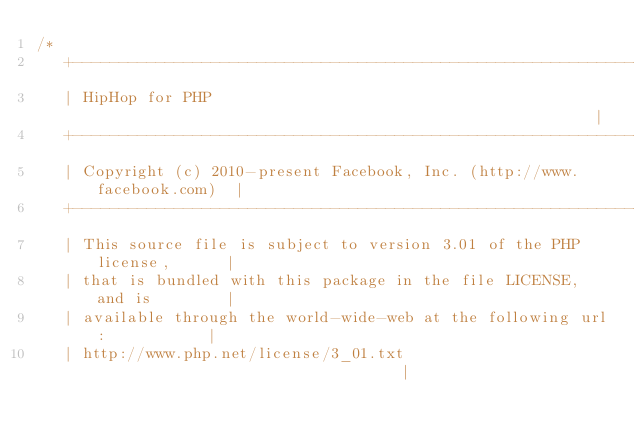<code> <loc_0><loc_0><loc_500><loc_500><_C_>/*
   +----------------------------------------------------------------------+
   | HipHop for PHP                                                       |
   +----------------------------------------------------------------------+
   | Copyright (c) 2010-present Facebook, Inc. (http://www.facebook.com)  |
   +----------------------------------------------------------------------+
   | This source file is subject to version 3.01 of the PHP license,      |
   | that is bundled with this package in the file LICENSE, and is        |
   | available through the world-wide-web at the following url:           |
   | http://www.php.net/license/3_01.txt                                  |</code> 